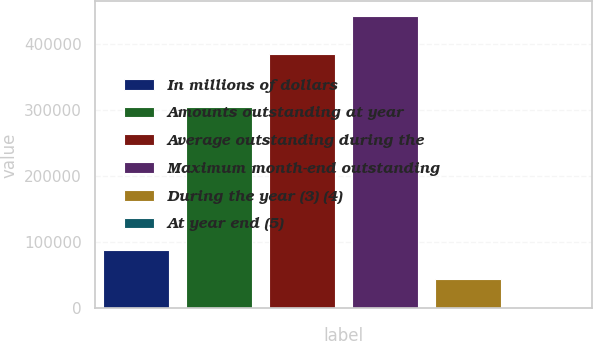<chart> <loc_0><loc_0><loc_500><loc_500><bar_chart><fcel>In millions of dollars<fcel>Amounts outstanding at year<fcel>Average outstanding during the<fcel>Maximum month-end outstanding<fcel>During the year (3) (4)<fcel>At year end (5)<nl><fcel>88372.4<fcel>304243<fcel>385199<fcel>441844<fcel>44188.5<fcel>4.52<nl></chart> 